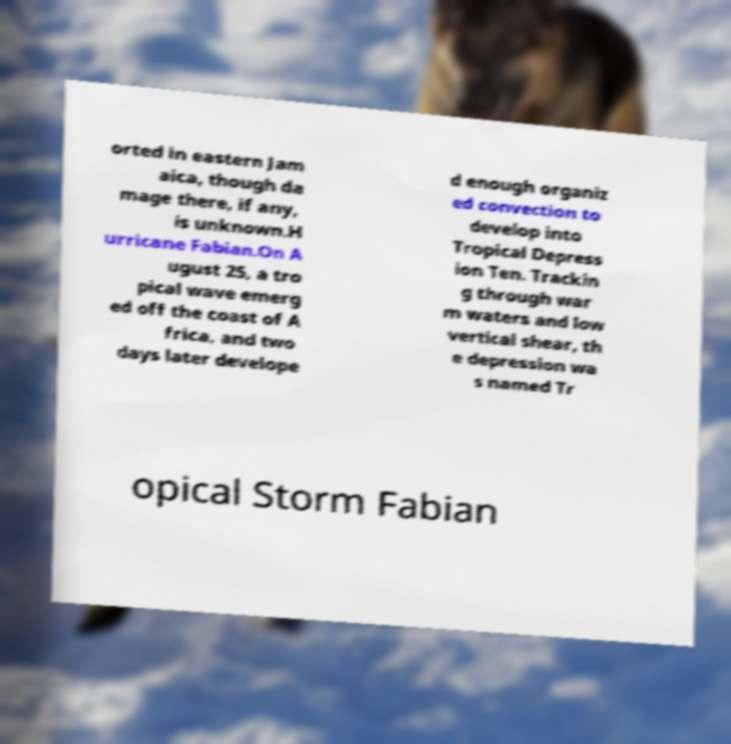Can you read and provide the text displayed in the image?This photo seems to have some interesting text. Can you extract and type it out for me? orted in eastern Jam aica, though da mage there, if any, is unknown.H urricane Fabian.On A ugust 25, a tro pical wave emerg ed off the coast of A frica, and two days later develope d enough organiz ed convection to develop into Tropical Depress ion Ten. Trackin g through war m waters and low vertical shear, th e depression wa s named Tr opical Storm Fabian 